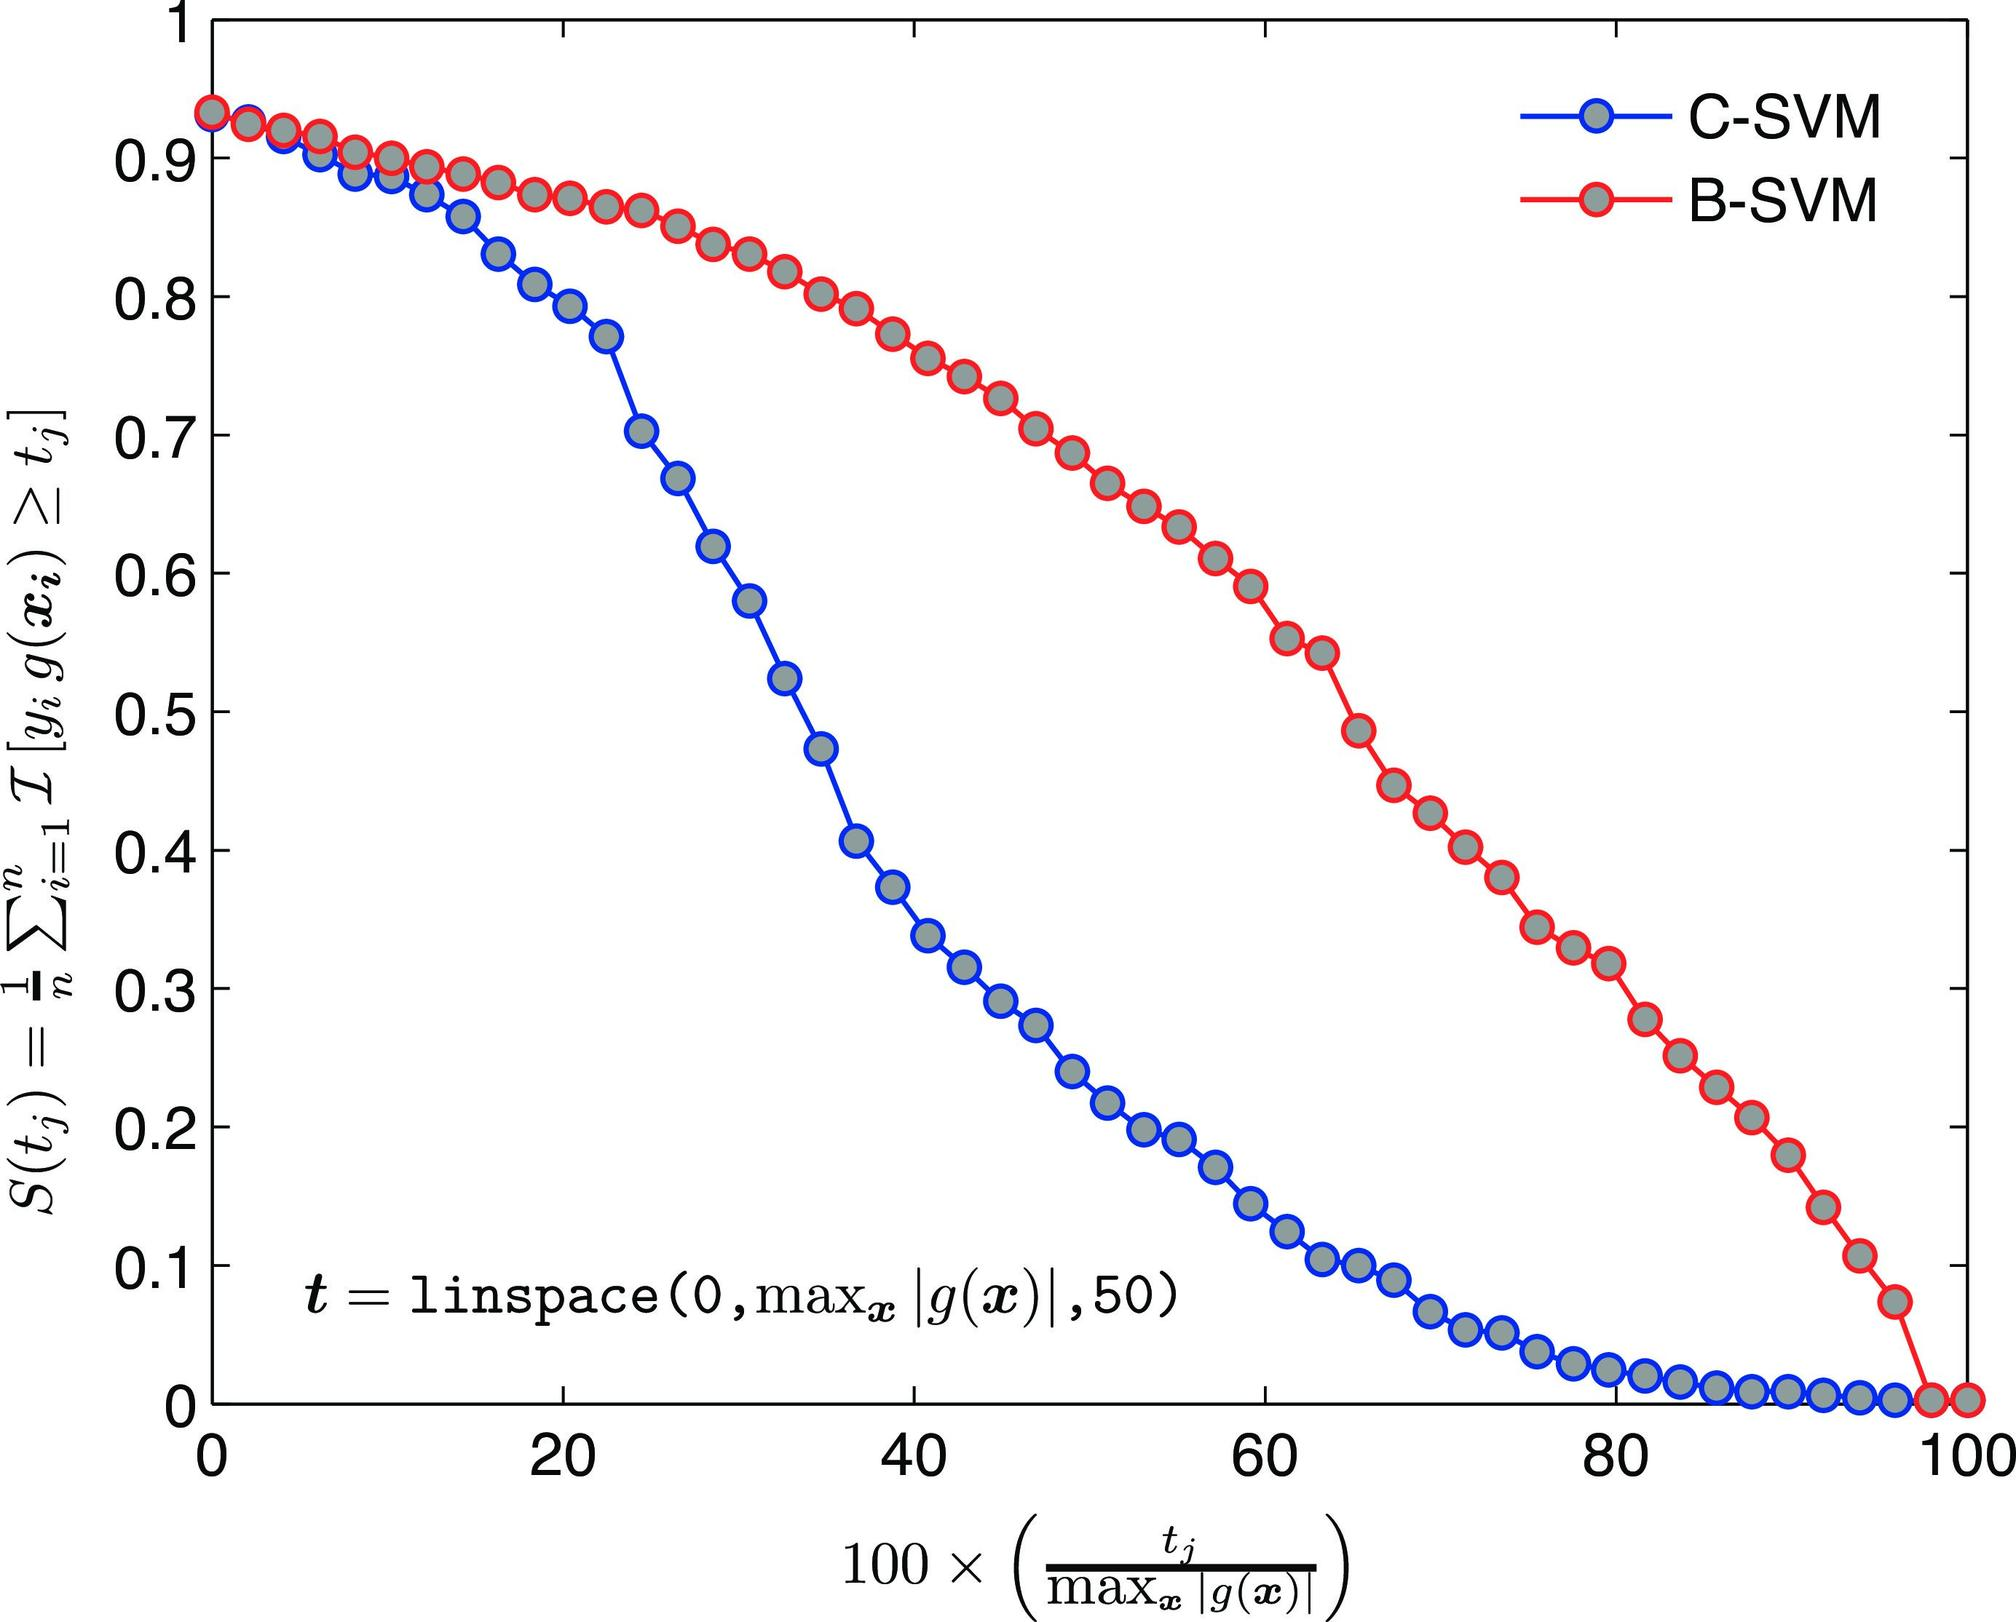Could you explain what the y-axis represents in this figure? Certainly! The y-axis of the graph represents the function \( S(t_j) \), which is a measure of the performance or accuracy of the SVM models being compared. This function quantifies some aspect of classifier performance, likely related to the classification error or another metric that captures the efficiency of the SVM model. Typically, a value of 1 or close to it would represent perfect performance, while values decreasing towards 0 would indicate a decline in performance. This function helps visualize how the performance of each model changes with different values of \( t \). 